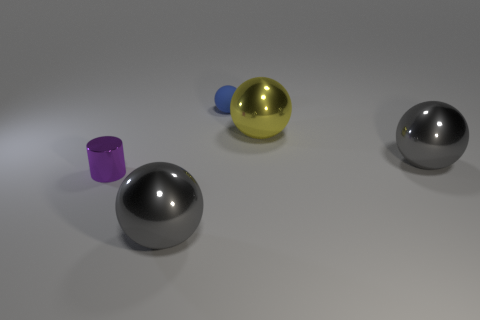Subtract all big yellow balls. How many balls are left? 3 Subtract all purple cubes. How many gray balls are left? 2 Add 2 big red things. How many objects exist? 7 Subtract all yellow spheres. How many spheres are left? 3 Subtract all cylinders. How many objects are left? 4 Subtract all blue balls. Subtract all red cylinders. How many balls are left? 3 Add 1 big gray metal spheres. How many big gray metal spheres exist? 3 Subtract 0 gray blocks. How many objects are left? 5 Subtract all blue rubber spheres. Subtract all large balls. How many objects are left? 1 Add 5 big gray objects. How many big gray objects are left? 7 